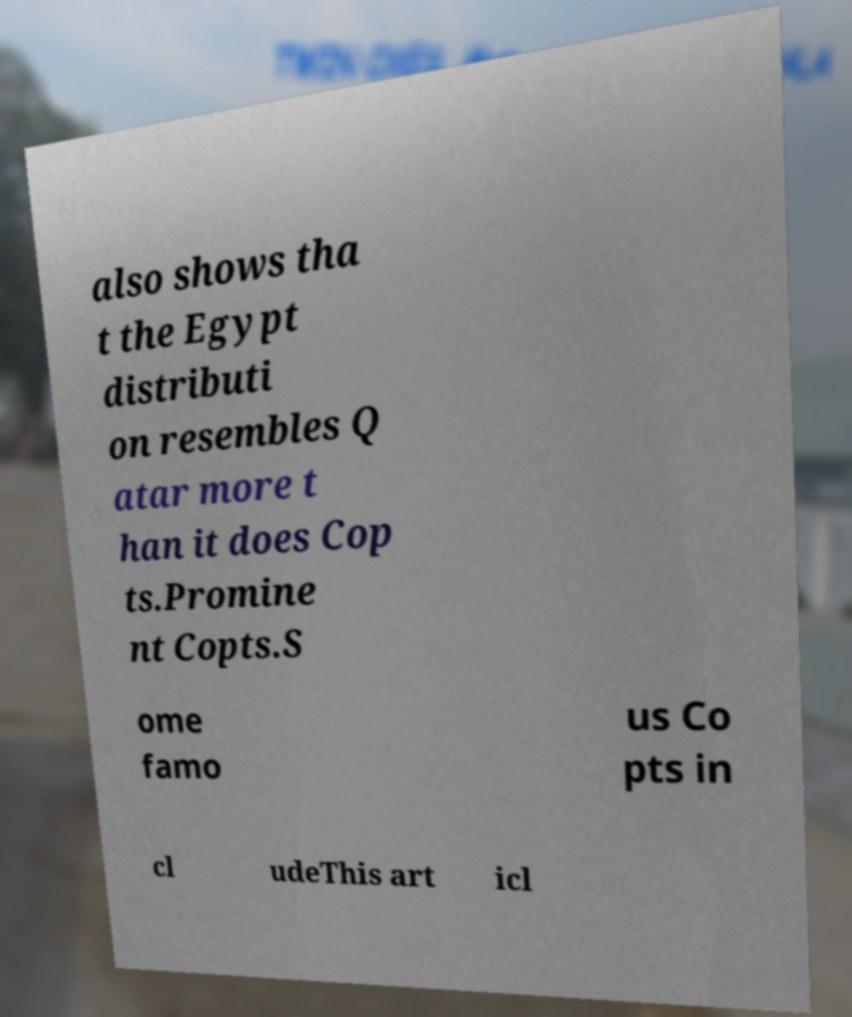Can you accurately transcribe the text from the provided image for me? also shows tha t the Egypt distributi on resembles Q atar more t han it does Cop ts.Promine nt Copts.S ome famo us Co pts in cl udeThis art icl 